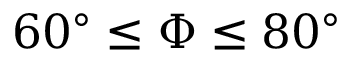<formula> <loc_0><loc_0><loc_500><loc_500>6 0 ^ { \circ } \leq \Phi \leq 8 0 ^ { \circ }</formula> 